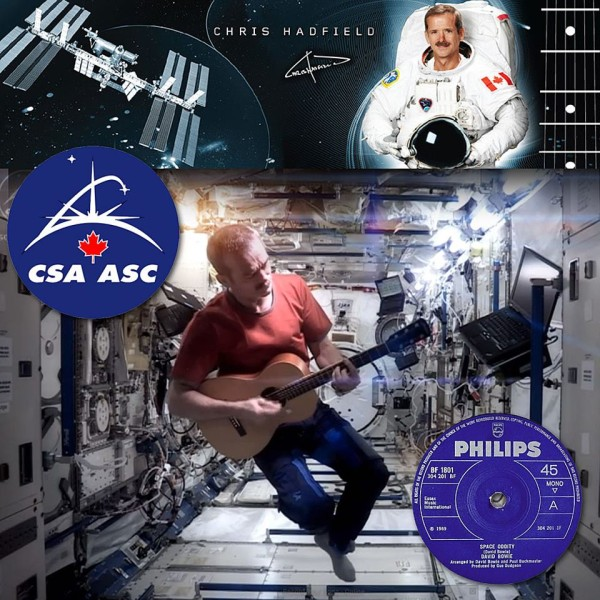How do the various elements in this collage contribute to portraying Chris Hadfield’s career and personal interests? This collage creatively encapsulates Chris Hadfield’s dual identity as an astronaut and a musician. The images of him in a space suit and playing guitar aboard the ISS vividly portray his professional career in the Canadian Space Agency as well as his passion for music. The inclusion of the International Space Station and the vinyl record of 'Space Oddity' highlight significant aspects of his life — his remarkable stint in space and his iconic musical performance. This multimedia approach serves not only as a biography but also as a celebration of his multidimensional persona, blending science with art. 